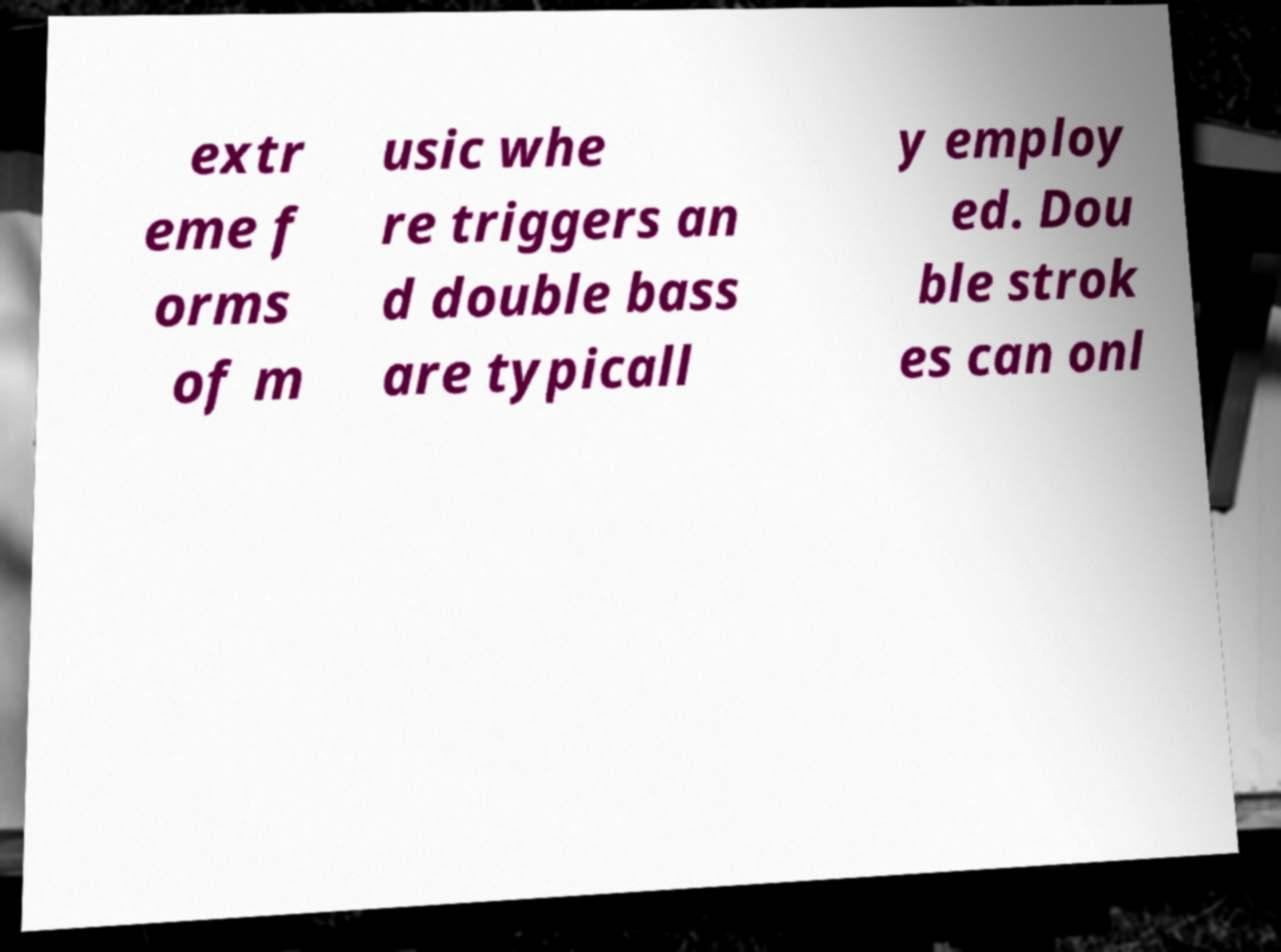I need the written content from this picture converted into text. Can you do that? extr eme f orms of m usic whe re triggers an d double bass are typicall y employ ed. Dou ble strok es can onl 